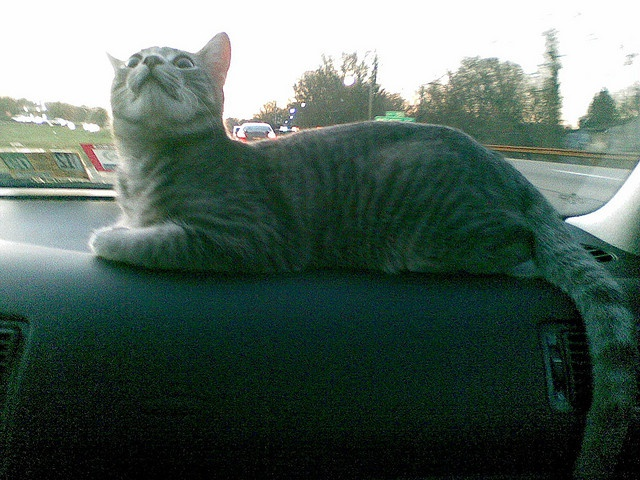Describe the objects in this image and their specific colors. I can see car in white, black, teal, darkgray, and lightgray tones, cat in white, black, darkgreen, teal, and gray tones, car in white, darkgray, lightblue, and gray tones, and traffic light in white, blue, and lavender tones in this image. 